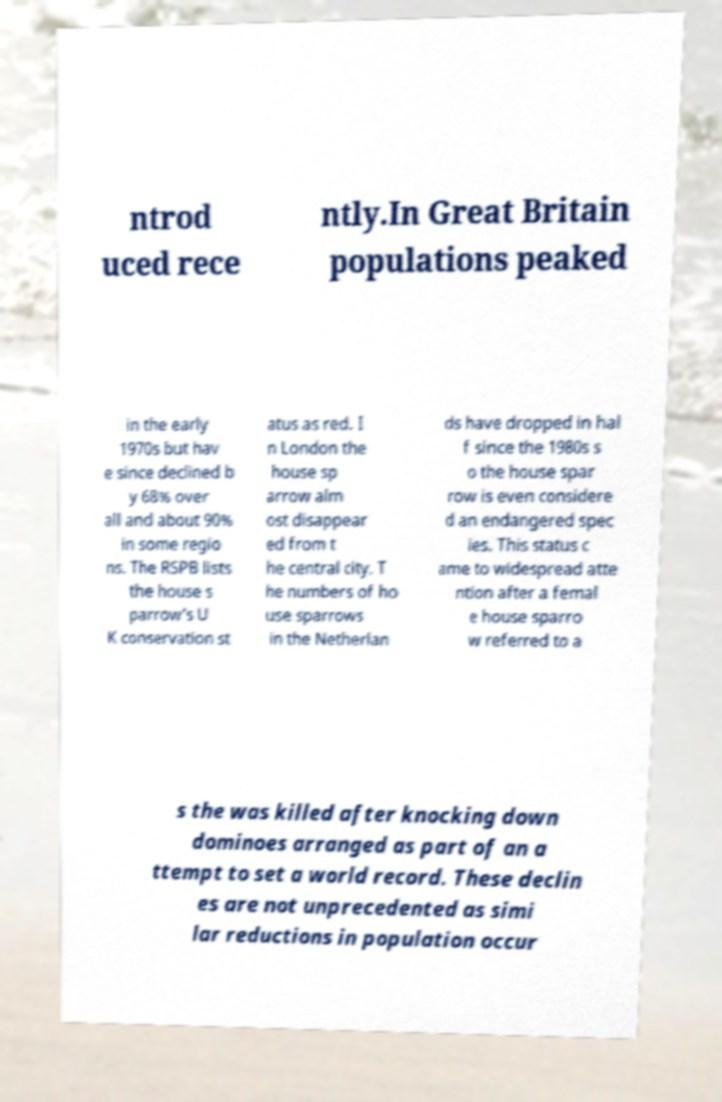For documentation purposes, I need the text within this image transcribed. Could you provide that? ntrod uced rece ntly.In Great Britain populations peaked in the early 1970s but hav e since declined b y 68% over all and about 90% in some regio ns. The RSPB lists the house s parrow's U K conservation st atus as red. I n London the house sp arrow alm ost disappear ed from t he central city. T he numbers of ho use sparrows in the Netherlan ds have dropped in hal f since the 1980s s o the house spar row is even considere d an endangered spec ies. This status c ame to widespread atte ntion after a femal e house sparro w referred to a s the was killed after knocking down dominoes arranged as part of an a ttempt to set a world record. These declin es are not unprecedented as simi lar reductions in population occur 